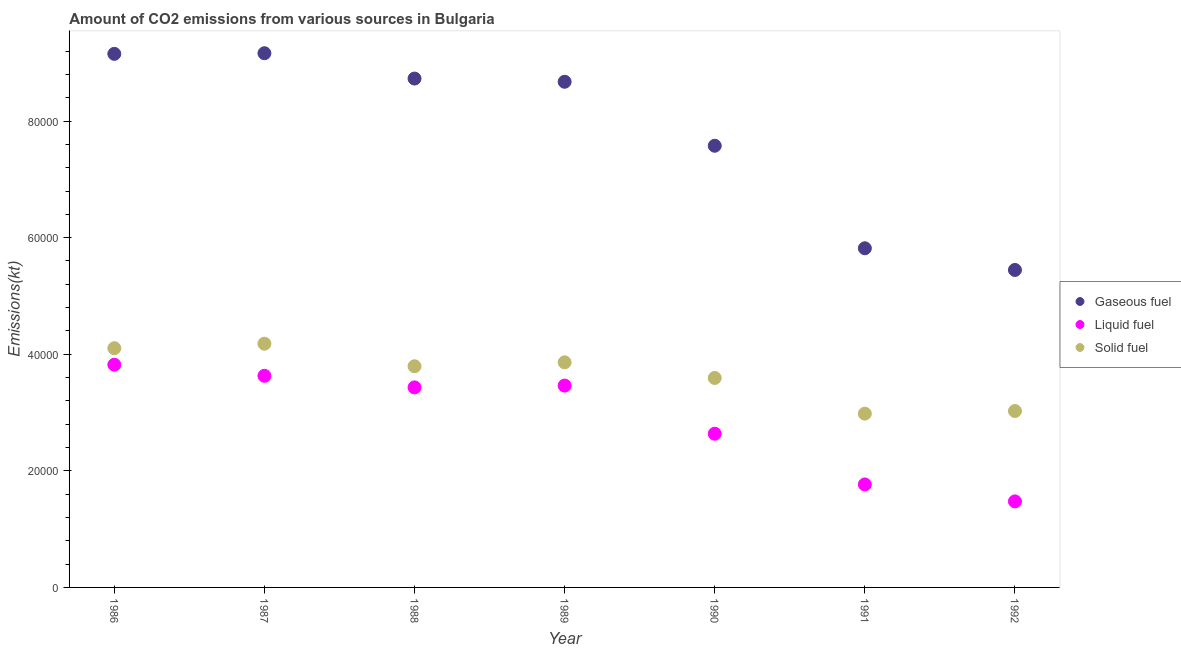Is the number of dotlines equal to the number of legend labels?
Keep it short and to the point. Yes. What is the amount of co2 emissions from liquid fuel in 1989?
Provide a short and direct response. 3.46e+04. Across all years, what is the maximum amount of co2 emissions from solid fuel?
Your answer should be very brief. 4.18e+04. Across all years, what is the minimum amount of co2 emissions from liquid fuel?
Your answer should be compact. 1.48e+04. In which year was the amount of co2 emissions from gaseous fuel minimum?
Your response must be concise. 1992. What is the total amount of co2 emissions from liquid fuel in the graph?
Your answer should be compact. 2.02e+05. What is the difference between the amount of co2 emissions from liquid fuel in 1987 and that in 1990?
Make the answer very short. 9937.57. What is the difference between the amount of co2 emissions from gaseous fuel in 1990 and the amount of co2 emissions from liquid fuel in 1986?
Your answer should be compact. 3.76e+04. What is the average amount of co2 emissions from solid fuel per year?
Your answer should be compact. 3.65e+04. In the year 1989, what is the difference between the amount of co2 emissions from solid fuel and amount of co2 emissions from liquid fuel?
Make the answer very short. 3986.03. What is the ratio of the amount of co2 emissions from gaseous fuel in 1986 to that in 1991?
Make the answer very short. 1.57. Is the amount of co2 emissions from solid fuel in 1987 less than that in 1989?
Make the answer very short. No. Is the difference between the amount of co2 emissions from gaseous fuel in 1989 and 1991 greater than the difference between the amount of co2 emissions from liquid fuel in 1989 and 1991?
Your answer should be compact. Yes. What is the difference between the highest and the second highest amount of co2 emissions from liquid fuel?
Offer a terse response. 1903.17. What is the difference between the highest and the lowest amount of co2 emissions from gaseous fuel?
Make the answer very short. 3.72e+04. Does the amount of co2 emissions from liquid fuel monotonically increase over the years?
Provide a succinct answer. No. Is the amount of co2 emissions from gaseous fuel strictly less than the amount of co2 emissions from solid fuel over the years?
Offer a terse response. No. How many years are there in the graph?
Your answer should be very brief. 7. What is the difference between two consecutive major ticks on the Y-axis?
Offer a terse response. 2.00e+04. How are the legend labels stacked?
Give a very brief answer. Vertical. What is the title of the graph?
Ensure brevity in your answer.  Amount of CO2 emissions from various sources in Bulgaria. Does "Unemployment benefits" appear as one of the legend labels in the graph?
Keep it short and to the point. No. What is the label or title of the X-axis?
Make the answer very short. Year. What is the label or title of the Y-axis?
Offer a terse response. Emissions(kt). What is the Emissions(kt) of Gaseous fuel in 1986?
Your answer should be compact. 9.15e+04. What is the Emissions(kt) of Liquid fuel in 1986?
Ensure brevity in your answer.  3.82e+04. What is the Emissions(kt) of Solid fuel in 1986?
Your answer should be compact. 4.10e+04. What is the Emissions(kt) in Gaseous fuel in 1987?
Your answer should be very brief. 9.16e+04. What is the Emissions(kt) of Liquid fuel in 1987?
Make the answer very short. 3.63e+04. What is the Emissions(kt) in Solid fuel in 1987?
Provide a succinct answer. 4.18e+04. What is the Emissions(kt) of Gaseous fuel in 1988?
Your answer should be very brief. 8.73e+04. What is the Emissions(kt) in Liquid fuel in 1988?
Make the answer very short. 3.43e+04. What is the Emissions(kt) of Solid fuel in 1988?
Your response must be concise. 3.79e+04. What is the Emissions(kt) in Gaseous fuel in 1989?
Your response must be concise. 8.67e+04. What is the Emissions(kt) in Liquid fuel in 1989?
Provide a short and direct response. 3.46e+04. What is the Emissions(kt) in Solid fuel in 1989?
Your answer should be very brief. 3.86e+04. What is the Emissions(kt) of Gaseous fuel in 1990?
Your answer should be very brief. 7.58e+04. What is the Emissions(kt) in Liquid fuel in 1990?
Offer a very short reply. 2.64e+04. What is the Emissions(kt) of Solid fuel in 1990?
Offer a terse response. 3.59e+04. What is the Emissions(kt) in Gaseous fuel in 1991?
Offer a very short reply. 5.82e+04. What is the Emissions(kt) of Liquid fuel in 1991?
Give a very brief answer. 1.77e+04. What is the Emissions(kt) in Solid fuel in 1991?
Give a very brief answer. 2.98e+04. What is the Emissions(kt) of Gaseous fuel in 1992?
Provide a succinct answer. 5.45e+04. What is the Emissions(kt) in Liquid fuel in 1992?
Ensure brevity in your answer.  1.48e+04. What is the Emissions(kt) of Solid fuel in 1992?
Ensure brevity in your answer.  3.03e+04. Across all years, what is the maximum Emissions(kt) in Gaseous fuel?
Keep it short and to the point. 9.16e+04. Across all years, what is the maximum Emissions(kt) in Liquid fuel?
Provide a short and direct response. 3.82e+04. Across all years, what is the maximum Emissions(kt) in Solid fuel?
Offer a very short reply. 4.18e+04. Across all years, what is the minimum Emissions(kt) in Gaseous fuel?
Your response must be concise. 5.45e+04. Across all years, what is the minimum Emissions(kt) in Liquid fuel?
Make the answer very short. 1.48e+04. Across all years, what is the minimum Emissions(kt) of Solid fuel?
Give a very brief answer. 2.98e+04. What is the total Emissions(kt) in Gaseous fuel in the graph?
Offer a very short reply. 5.46e+05. What is the total Emissions(kt) of Liquid fuel in the graph?
Give a very brief answer. 2.02e+05. What is the total Emissions(kt) of Solid fuel in the graph?
Offer a terse response. 2.55e+05. What is the difference between the Emissions(kt) in Gaseous fuel in 1986 and that in 1987?
Offer a very short reply. -106.34. What is the difference between the Emissions(kt) of Liquid fuel in 1986 and that in 1987?
Your answer should be compact. 1903.17. What is the difference between the Emissions(kt) in Solid fuel in 1986 and that in 1987?
Offer a terse response. -770.07. What is the difference between the Emissions(kt) in Gaseous fuel in 1986 and that in 1988?
Offer a very short reply. 4239.05. What is the difference between the Emissions(kt) of Liquid fuel in 1986 and that in 1988?
Provide a short and direct response. 3887.02. What is the difference between the Emissions(kt) of Solid fuel in 1986 and that in 1988?
Make the answer very short. 3098.61. What is the difference between the Emissions(kt) in Gaseous fuel in 1986 and that in 1989?
Offer a terse response. 4789.1. What is the difference between the Emissions(kt) of Liquid fuel in 1986 and that in 1989?
Your answer should be compact. 3578.99. What is the difference between the Emissions(kt) in Solid fuel in 1986 and that in 1989?
Provide a succinct answer. 2427.55. What is the difference between the Emissions(kt) in Gaseous fuel in 1986 and that in 1990?
Give a very brief answer. 1.58e+04. What is the difference between the Emissions(kt) of Liquid fuel in 1986 and that in 1990?
Offer a terse response. 1.18e+04. What is the difference between the Emissions(kt) in Solid fuel in 1986 and that in 1990?
Keep it short and to the point. 5104.46. What is the difference between the Emissions(kt) of Gaseous fuel in 1986 and that in 1991?
Provide a short and direct response. 3.34e+04. What is the difference between the Emissions(kt) of Liquid fuel in 1986 and that in 1991?
Your response must be concise. 2.05e+04. What is the difference between the Emissions(kt) of Solid fuel in 1986 and that in 1991?
Your answer should be very brief. 1.12e+04. What is the difference between the Emissions(kt) of Gaseous fuel in 1986 and that in 1992?
Keep it short and to the point. 3.71e+04. What is the difference between the Emissions(kt) in Liquid fuel in 1986 and that in 1992?
Provide a succinct answer. 2.34e+04. What is the difference between the Emissions(kt) of Solid fuel in 1986 and that in 1992?
Keep it short and to the point. 1.08e+04. What is the difference between the Emissions(kt) of Gaseous fuel in 1987 and that in 1988?
Offer a very short reply. 4345.4. What is the difference between the Emissions(kt) in Liquid fuel in 1987 and that in 1988?
Keep it short and to the point. 1983.85. What is the difference between the Emissions(kt) of Solid fuel in 1987 and that in 1988?
Your answer should be compact. 3868.68. What is the difference between the Emissions(kt) in Gaseous fuel in 1987 and that in 1989?
Your answer should be very brief. 4895.44. What is the difference between the Emissions(kt) in Liquid fuel in 1987 and that in 1989?
Give a very brief answer. 1675.82. What is the difference between the Emissions(kt) of Solid fuel in 1987 and that in 1989?
Offer a very short reply. 3197.62. What is the difference between the Emissions(kt) of Gaseous fuel in 1987 and that in 1990?
Keep it short and to the point. 1.59e+04. What is the difference between the Emissions(kt) in Liquid fuel in 1987 and that in 1990?
Keep it short and to the point. 9937.57. What is the difference between the Emissions(kt) of Solid fuel in 1987 and that in 1990?
Keep it short and to the point. 5874.53. What is the difference between the Emissions(kt) of Gaseous fuel in 1987 and that in 1991?
Offer a very short reply. 3.35e+04. What is the difference between the Emissions(kt) in Liquid fuel in 1987 and that in 1991?
Give a very brief answer. 1.86e+04. What is the difference between the Emissions(kt) in Solid fuel in 1987 and that in 1991?
Offer a very short reply. 1.20e+04. What is the difference between the Emissions(kt) in Gaseous fuel in 1987 and that in 1992?
Offer a very short reply. 3.72e+04. What is the difference between the Emissions(kt) in Liquid fuel in 1987 and that in 1992?
Provide a succinct answer. 2.15e+04. What is the difference between the Emissions(kt) in Solid fuel in 1987 and that in 1992?
Provide a short and direct response. 1.15e+04. What is the difference between the Emissions(kt) of Gaseous fuel in 1988 and that in 1989?
Make the answer very short. 550.05. What is the difference between the Emissions(kt) in Liquid fuel in 1988 and that in 1989?
Provide a succinct answer. -308.03. What is the difference between the Emissions(kt) in Solid fuel in 1988 and that in 1989?
Provide a short and direct response. -671.06. What is the difference between the Emissions(kt) in Gaseous fuel in 1988 and that in 1990?
Your response must be concise. 1.15e+04. What is the difference between the Emissions(kt) of Liquid fuel in 1988 and that in 1990?
Offer a terse response. 7953.72. What is the difference between the Emissions(kt) of Solid fuel in 1988 and that in 1990?
Ensure brevity in your answer.  2005.85. What is the difference between the Emissions(kt) in Gaseous fuel in 1988 and that in 1991?
Keep it short and to the point. 2.91e+04. What is the difference between the Emissions(kt) in Liquid fuel in 1988 and that in 1991?
Offer a very short reply. 1.66e+04. What is the difference between the Emissions(kt) in Solid fuel in 1988 and that in 1991?
Your response must be concise. 8129.74. What is the difference between the Emissions(kt) in Gaseous fuel in 1988 and that in 1992?
Your answer should be very brief. 3.28e+04. What is the difference between the Emissions(kt) of Liquid fuel in 1988 and that in 1992?
Your answer should be very brief. 1.96e+04. What is the difference between the Emissions(kt) of Solid fuel in 1988 and that in 1992?
Offer a terse response. 7678.7. What is the difference between the Emissions(kt) in Gaseous fuel in 1989 and that in 1990?
Your answer should be very brief. 1.10e+04. What is the difference between the Emissions(kt) of Liquid fuel in 1989 and that in 1990?
Your answer should be very brief. 8261.75. What is the difference between the Emissions(kt) of Solid fuel in 1989 and that in 1990?
Make the answer very short. 2676.91. What is the difference between the Emissions(kt) in Gaseous fuel in 1989 and that in 1991?
Offer a terse response. 2.86e+04. What is the difference between the Emissions(kt) in Liquid fuel in 1989 and that in 1991?
Offer a terse response. 1.70e+04. What is the difference between the Emissions(kt) in Solid fuel in 1989 and that in 1991?
Give a very brief answer. 8800.8. What is the difference between the Emissions(kt) in Gaseous fuel in 1989 and that in 1992?
Your answer should be compact. 3.23e+04. What is the difference between the Emissions(kt) of Liquid fuel in 1989 and that in 1992?
Offer a very short reply. 1.99e+04. What is the difference between the Emissions(kt) of Solid fuel in 1989 and that in 1992?
Your answer should be very brief. 8349.76. What is the difference between the Emissions(kt) in Gaseous fuel in 1990 and that in 1991?
Offer a terse response. 1.76e+04. What is the difference between the Emissions(kt) of Liquid fuel in 1990 and that in 1991?
Make the answer very short. 8694.46. What is the difference between the Emissions(kt) in Solid fuel in 1990 and that in 1991?
Offer a very short reply. 6123.89. What is the difference between the Emissions(kt) of Gaseous fuel in 1990 and that in 1992?
Keep it short and to the point. 2.13e+04. What is the difference between the Emissions(kt) in Liquid fuel in 1990 and that in 1992?
Keep it short and to the point. 1.16e+04. What is the difference between the Emissions(kt) in Solid fuel in 1990 and that in 1992?
Ensure brevity in your answer.  5672.85. What is the difference between the Emissions(kt) in Gaseous fuel in 1991 and that in 1992?
Your answer should be compact. 3718.34. What is the difference between the Emissions(kt) in Liquid fuel in 1991 and that in 1992?
Your response must be concise. 2907.93. What is the difference between the Emissions(kt) in Solid fuel in 1991 and that in 1992?
Your answer should be very brief. -451.04. What is the difference between the Emissions(kt) of Gaseous fuel in 1986 and the Emissions(kt) of Liquid fuel in 1987?
Keep it short and to the point. 5.52e+04. What is the difference between the Emissions(kt) of Gaseous fuel in 1986 and the Emissions(kt) of Solid fuel in 1987?
Offer a very short reply. 4.97e+04. What is the difference between the Emissions(kt) of Liquid fuel in 1986 and the Emissions(kt) of Solid fuel in 1987?
Your answer should be very brief. -3604.66. What is the difference between the Emissions(kt) in Gaseous fuel in 1986 and the Emissions(kt) in Liquid fuel in 1988?
Your answer should be compact. 5.72e+04. What is the difference between the Emissions(kt) in Gaseous fuel in 1986 and the Emissions(kt) in Solid fuel in 1988?
Offer a very short reply. 5.36e+04. What is the difference between the Emissions(kt) in Liquid fuel in 1986 and the Emissions(kt) in Solid fuel in 1988?
Provide a succinct answer. 264.02. What is the difference between the Emissions(kt) of Gaseous fuel in 1986 and the Emissions(kt) of Liquid fuel in 1989?
Provide a succinct answer. 5.69e+04. What is the difference between the Emissions(kt) in Gaseous fuel in 1986 and the Emissions(kt) in Solid fuel in 1989?
Ensure brevity in your answer.  5.29e+04. What is the difference between the Emissions(kt) of Liquid fuel in 1986 and the Emissions(kt) of Solid fuel in 1989?
Keep it short and to the point. -407.04. What is the difference between the Emissions(kt) in Gaseous fuel in 1986 and the Emissions(kt) in Liquid fuel in 1990?
Your answer should be compact. 6.52e+04. What is the difference between the Emissions(kt) in Gaseous fuel in 1986 and the Emissions(kt) in Solid fuel in 1990?
Keep it short and to the point. 5.56e+04. What is the difference between the Emissions(kt) in Liquid fuel in 1986 and the Emissions(kt) in Solid fuel in 1990?
Offer a terse response. 2269.87. What is the difference between the Emissions(kt) of Gaseous fuel in 1986 and the Emissions(kt) of Liquid fuel in 1991?
Provide a short and direct response. 7.39e+04. What is the difference between the Emissions(kt) of Gaseous fuel in 1986 and the Emissions(kt) of Solid fuel in 1991?
Your response must be concise. 6.17e+04. What is the difference between the Emissions(kt) of Liquid fuel in 1986 and the Emissions(kt) of Solid fuel in 1991?
Provide a succinct answer. 8393.76. What is the difference between the Emissions(kt) of Gaseous fuel in 1986 and the Emissions(kt) of Liquid fuel in 1992?
Keep it short and to the point. 7.68e+04. What is the difference between the Emissions(kt) of Gaseous fuel in 1986 and the Emissions(kt) of Solid fuel in 1992?
Your answer should be very brief. 6.13e+04. What is the difference between the Emissions(kt) in Liquid fuel in 1986 and the Emissions(kt) in Solid fuel in 1992?
Your response must be concise. 7942.72. What is the difference between the Emissions(kt) of Gaseous fuel in 1987 and the Emissions(kt) of Liquid fuel in 1988?
Provide a succinct answer. 5.73e+04. What is the difference between the Emissions(kt) in Gaseous fuel in 1987 and the Emissions(kt) in Solid fuel in 1988?
Ensure brevity in your answer.  5.37e+04. What is the difference between the Emissions(kt) in Liquid fuel in 1987 and the Emissions(kt) in Solid fuel in 1988?
Provide a short and direct response. -1639.15. What is the difference between the Emissions(kt) in Gaseous fuel in 1987 and the Emissions(kt) in Liquid fuel in 1989?
Provide a short and direct response. 5.70e+04. What is the difference between the Emissions(kt) in Gaseous fuel in 1987 and the Emissions(kt) in Solid fuel in 1989?
Your answer should be very brief. 5.30e+04. What is the difference between the Emissions(kt) in Liquid fuel in 1987 and the Emissions(kt) in Solid fuel in 1989?
Your answer should be very brief. -2310.21. What is the difference between the Emissions(kt) of Gaseous fuel in 1987 and the Emissions(kt) of Liquid fuel in 1990?
Provide a succinct answer. 6.53e+04. What is the difference between the Emissions(kt) in Gaseous fuel in 1987 and the Emissions(kt) in Solid fuel in 1990?
Offer a terse response. 5.57e+04. What is the difference between the Emissions(kt) in Liquid fuel in 1987 and the Emissions(kt) in Solid fuel in 1990?
Offer a terse response. 366.7. What is the difference between the Emissions(kt) in Gaseous fuel in 1987 and the Emissions(kt) in Liquid fuel in 1991?
Make the answer very short. 7.40e+04. What is the difference between the Emissions(kt) in Gaseous fuel in 1987 and the Emissions(kt) in Solid fuel in 1991?
Keep it short and to the point. 6.18e+04. What is the difference between the Emissions(kt) of Liquid fuel in 1987 and the Emissions(kt) of Solid fuel in 1991?
Provide a short and direct response. 6490.59. What is the difference between the Emissions(kt) of Gaseous fuel in 1987 and the Emissions(kt) of Liquid fuel in 1992?
Your answer should be compact. 7.69e+04. What is the difference between the Emissions(kt) of Gaseous fuel in 1987 and the Emissions(kt) of Solid fuel in 1992?
Your response must be concise. 6.14e+04. What is the difference between the Emissions(kt) of Liquid fuel in 1987 and the Emissions(kt) of Solid fuel in 1992?
Keep it short and to the point. 6039.55. What is the difference between the Emissions(kt) of Gaseous fuel in 1988 and the Emissions(kt) of Liquid fuel in 1989?
Keep it short and to the point. 5.27e+04. What is the difference between the Emissions(kt) of Gaseous fuel in 1988 and the Emissions(kt) of Solid fuel in 1989?
Ensure brevity in your answer.  4.87e+04. What is the difference between the Emissions(kt) of Liquid fuel in 1988 and the Emissions(kt) of Solid fuel in 1989?
Your answer should be compact. -4294.06. What is the difference between the Emissions(kt) in Gaseous fuel in 1988 and the Emissions(kt) in Liquid fuel in 1990?
Keep it short and to the point. 6.09e+04. What is the difference between the Emissions(kt) in Gaseous fuel in 1988 and the Emissions(kt) in Solid fuel in 1990?
Your answer should be compact. 5.14e+04. What is the difference between the Emissions(kt) of Liquid fuel in 1988 and the Emissions(kt) of Solid fuel in 1990?
Provide a short and direct response. -1617.15. What is the difference between the Emissions(kt) of Gaseous fuel in 1988 and the Emissions(kt) of Liquid fuel in 1991?
Provide a short and direct response. 6.96e+04. What is the difference between the Emissions(kt) in Gaseous fuel in 1988 and the Emissions(kt) in Solid fuel in 1991?
Your answer should be very brief. 5.75e+04. What is the difference between the Emissions(kt) of Liquid fuel in 1988 and the Emissions(kt) of Solid fuel in 1991?
Make the answer very short. 4506.74. What is the difference between the Emissions(kt) in Gaseous fuel in 1988 and the Emissions(kt) in Liquid fuel in 1992?
Give a very brief answer. 7.25e+04. What is the difference between the Emissions(kt) in Gaseous fuel in 1988 and the Emissions(kt) in Solid fuel in 1992?
Keep it short and to the point. 5.70e+04. What is the difference between the Emissions(kt) of Liquid fuel in 1988 and the Emissions(kt) of Solid fuel in 1992?
Give a very brief answer. 4055.7. What is the difference between the Emissions(kt) in Gaseous fuel in 1989 and the Emissions(kt) in Liquid fuel in 1990?
Give a very brief answer. 6.04e+04. What is the difference between the Emissions(kt) of Gaseous fuel in 1989 and the Emissions(kt) of Solid fuel in 1990?
Your answer should be very brief. 5.08e+04. What is the difference between the Emissions(kt) of Liquid fuel in 1989 and the Emissions(kt) of Solid fuel in 1990?
Give a very brief answer. -1309.12. What is the difference between the Emissions(kt) of Gaseous fuel in 1989 and the Emissions(kt) of Liquid fuel in 1991?
Ensure brevity in your answer.  6.91e+04. What is the difference between the Emissions(kt) in Gaseous fuel in 1989 and the Emissions(kt) in Solid fuel in 1991?
Your answer should be compact. 5.69e+04. What is the difference between the Emissions(kt) of Liquid fuel in 1989 and the Emissions(kt) of Solid fuel in 1991?
Offer a very short reply. 4814.77. What is the difference between the Emissions(kt) of Gaseous fuel in 1989 and the Emissions(kt) of Liquid fuel in 1992?
Ensure brevity in your answer.  7.20e+04. What is the difference between the Emissions(kt) of Gaseous fuel in 1989 and the Emissions(kt) of Solid fuel in 1992?
Make the answer very short. 5.65e+04. What is the difference between the Emissions(kt) of Liquid fuel in 1989 and the Emissions(kt) of Solid fuel in 1992?
Your answer should be very brief. 4363.73. What is the difference between the Emissions(kt) of Gaseous fuel in 1990 and the Emissions(kt) of Liquid fuel in 1991?
Provide a succinct answer. 5.81e+04. What is the difference between the Emissions(kt) of Gaseous fuel in 1990 and the Emissions(kt) of Solid fuel in 1991?
Make the answer very short. 4.60e+04. What is the difference between the Emissions(kt) in Liquid fuel in 1990 and the Emissions(kt) in Solid fuel in 1991?
Your response must be concise. -3446.98. What is the difference between the Emissions(kt) of Gaseous fuel in 1990 and the Emissions(kt) of Liquid fuel in 1992?
Your answer should be very brief. 6.10e+04. What is the difference between the Emissions(kt) in Gaseous fuel in 1990 and the Emissions(kt) in Solid fuel in 1992?
Make the answer very short. 4.55e+04. What is the difference between the Emissions(kt) of Liquid fuel in 1990 and the Emissions(kt) of Solid fuel in 1992?
Provide a succinct answer. -3898.02. What is the difference between the Emissions(kt) in Gaseous fuel in 1991 and the Emissions(kt) in Liquid fuel in 1992?
Your answer should be very brief. 4.34e+04. What is the difference between the Emissions(kt) of Gaseous fuel in 1991 and the Emissions(kt) of Solid fuel in 1992?
Provide a succinct answer. 2.79e+04. What is the difference between the Emissions(kt) of Liquid fuel in 1991 and the Emissions(kt) of Solid fuel in 1992?
Ensure brevity in your answer.  -1.26e+04. What is the average Emissions(kt) of Gaseous fuel per year?
Give a very brief answer. 7.79e+04. What is the average Emissions(kt) in Liquid fuel per year?
Ensure brevity in your answer.  2.89e+04. What is the average Emissions(kt) in Solid fuel per year?
Your answer should be very brief. 3.65e+04. In the year 1986, what is the difference between the Emissions(kt) in Gaseous fuel and Emissions(kt) in Liquid fuel?
Your answer should be very brief. 5.33e+04. In the year 1986, what is the difference between the Emissions(kt) of Gaseous fuel and Emissions(kt) of Solid fuel?
Give a very brief answer. 5.05e+04. In the year 1986, what is the difference between the Emissions(kt) in Liquid fuel and Emissions(kt) in Solid fuel?
Provide a short and direct response. -2834.59. In the year 1987, what is the difference between the Emissions(kt) of Gaseous fuel and Emissions(kt) of Liquid fuel?
Give a very brief answer. 5.53e+04. In the year 1987, what is the difference between the Emissions(kt) in Gaseous fuel and Emissions(kt) in Solid fuel?
Offer a very short reply. 4.98e+04. In the year 1987, what is the difference between the Emissions(kt) of Liquid fuel and Emissions(kt) of Solid fuel?
Keep it short and to the point. -5507.83. In the year 1988, what is the difference between the Emissions(kt) of Gaseous fuel and Emissions(kt) of Liquid fuel?
Your answer should be compact. 5.30e+04. In the year 1988, what is the difference between the Emissions(kt) of Gaseous fuel and Emissions(kt) of Solid fuel?
Your answer should be very brief. 4.94e+04. In the year 1988, what is the difference between the Emissions(kt) of Liquid fuel and Emissions(kt) of Solid fuel?
Provide a short and direct response. -3623. In the year 1989, what is the difference between the Emissions(kt) of Gaseous fuel and Emissions(kt) of Liquid fuel?
Keep it short and to the point. 5.21e+04. In the year 1989, what is the difference between the Emissions(kt) of Gaseous fuel and Emissions(kt) of Solid fuel?
Make the answer very short. 4.81e+04. In the year 1989, what is the difference between the Emissions(kt) of Liquid fuel and Emissions(kt) of Solid fuel?
Keep it short and to the point. -3986.03. In the year 1990, what is the difference between the Emissions(kt) in Gaseous fuel and Emissions(kt) in Liquid fuel?
Offer a very short reply. 4.94e+04. In the year 1990, what is the difference between the Emissions(kt) of Gaseous fuel and Emissions(kt) of Solid fuel?
Give a very brief answer. 3.98e+04. In the year 1990, what is the difference between the Emissions(kt) of Liquid fuel and Emissions(kt) of Solid fuel?
Your answer should be very brief. -9570.87. In the year 1991, what is the difference between the Emissions(kt) of Gaseous fuel and Emissions(kt) of Liquid fuel?
Your answer should be very brief. 4.05e+04. In the year 1991, what is the difference between the Emissions(kt) of Gaseous fuel and Emissions(kt) of Solid fuel?
Keep it short and to the point. 2.84e+04. In the year 1991, what is the difference between the Emissions(kt) in Liquid fuel and Emissions(kt) in Solid fuel?
Your answer should be very brief. -1.21e+04. In the year 1992, what is the difference between the Emissions(kt) in Gaseous fuel and Emissions(kt) in Liquid fuel?
Your answer should be compact. 3.97e+04. In the year 1992, what is the difference between the Emissions(kt) of Gaseous fuel and Emissions(kt) of Solid fuel?
Provide a short and direct response. 2.42e+04. In the year 1992, what is the difference between the Emissions(kt) of Liquid fuel and Emissions(kt) of Solid fuel?
Your answer should be compact. -1.55e+04. What is the ratio of the Emissions(kt) in Liquid fuel in 1986 to that in 1987?
Your answer should be very brief. 1.05. What is the ratio of the Emissions(kt) in Solid fuel in 1986 to that in 1987?
Keep it short and to the point. 0.98. What is the ratio of the Emissions(kt) in Gaseous fuel in 1986 to that in 1988?
Make the answer very short. 1.05. What is the ratio of the Emissions(kt) of Liquid fuel in 1986 to that in 1988?
Your answer should be very brief. 1.11. What is the ratio of the Emissions(kt) in Solid fuel in 1986 to that in 1988?
Ensure brevity in your answer.  1.08. What is the ratio of the Emissions(kt) in Gaseous fuel in 1986 to that in 1989?
Provide a succinct answer. 1.06. What is the ratio of the Emissions(kt) of Liquid fuel in 1986 to that in 1989?
Offer a very short reply. 1.1. What is the ratio of the Emissions(kt) in Solid fuel in 1986 to that in 1989?
Provide a short and direct response. 1.06. What is the ratio of the Emissions(kt) of Gaseous fuel in 1986 to that in 1990?
Make the answer very short. 1.21. What is the ratio of the Emissions(kt) of Liquid fuel in 1986 to that in 1990?
Your response must be concise. 1.45. What is the ratio of the Emissions(kt) of Solid fuel in 1986 to that in 1990?
Your answer should be compact. 1.14. What is the ratio of the Emissions(kt) of Gaseous fuel in 1986 to that in 1991?
Your response must be concise. 1.57. What is the ratio of the Emissions(kt) in Liquid fuel in 1986 to that in 1991?
Offer a very short reply. 2.16. What is the ratio of the Emissions(kt) in Solid fuel in 1986 to that in 1991?
Offer a terse response. 1.38. What is the ratio of the Emissions(kt) of Gaseous fuel in 1986 to that in 1992?
Offer a very short reply. 1.68. What is the ratio of the Emissions(kt) in Liquid fuel in 1986 to that in 1992?
Ensure brevity in your answer.  2.59. What is the ratio of the Emissions(kt) in Solid fuel in 1986 to that in 1992?
Ensure brevity in your answer.  1.36. What is the ratio of the Emissions(kt) of Gaseous fuel in 1987 to that in 1988?
Give a very brief answer. 1.05. What is the ratio of the Emissions(kt) of Liquid fuel in 1987 to that in 1988?
Your response must be concise. 1.06. What is the ratio of the Emissions(kt) of Solid fuel in 1987 to that in 1988?
Give a very brief answer. 1.1. What is the ratio of the Emissions(kt) in Gaseous fuel in 1987 to that in 1989?
Provide a short and direct response. 1.06. What is the ratio of the Emissions(kt) of Liquid fuel in 1987 to that in 1989?
Ensure brevity in your answer.  1.05. What is the ratio of the Emissions(kt) in Solid fuel in 1987 to that in 1989?
Your response must be concise. 1.08. What is the ratio of the Emissions(kt) in Gaseous fuel in 1987 to that in 1990?
Provide a succinct answer. 1.21. What is the ratio of the Emissions(kt) of Liquid fuel in 1987 to that in 1990?
Your answer should be compact. 1.38. What is the ratio of the Emissions(kt) of Solid fuel in 1987 to that in 1990?
Offer a very short reply. 1.16. What is the ratio of the Emissions(kt) of Gaseous fuel in 1987 to that in 1991?
Make the answer very short. 1.58. What is the ratio of the Emissions(kt) in Liquid fuel in 1987 to that in 1991?
Your answer should be compact. 2.05. What is the ratio of the Emissions(kt) of Solid fuel in 1987 to that in 1991?
Offer a very short reply. 1.4. What is the ratio of the Emissions(kt) of Gaseous fuel in 1987 to that in 1992?
Provide a succinct answer. 1.68. What is the ratio of the Emissions(kt) of Liquid fuel in 1987 to that in 1992?
Keep it short and to the point. 2.46. What is the ratio of the Emissions(kt) of Solid fuel in 1987 to that in 1992?
Your answer should be compact. 1.38. What is the ratio of the Emissions(kt) in Solid fuel in 1988 to that in 1989?
Provide a short and direct response. 0.98. What is the ratio of the Emissions(kt) of Gaseous fuel in 1988 to that in 1990?
Give a very brief answer. 1.15. What is the ratio of the Emissions(kt) in Liquid fuel in 1988 to that in 1990?
Offer a terse response. 1.3. What is the ratio of the Emissions(kt) in Solid fuel in 1988 to that in 1990?
Ensure brevity in your answer.  1.06. What is the ratio of the Emissions(kt) of Gaseous fuel in 1988 to that in 1991?
Your answer should be compact. 1.5. What is the ratio of the Emissions(kt) of Liquid fuel in 1988 to that in 1991?
Ensure brevity in your answer.  1.94. What is the ratio of the Emissions(kt) in Solid fuel in 1988 to that in 1991?
Give a very brief answer. 1.27. What is the ratio of the Emissions(kt) in Gaseous fuel in 1988 to that in 1992?
Provide a short and direct response. 1.6. What is the ratio of the Emissions(kt) of Liquid fuel in 1988 to that in 1992?
Give a very brief answer. 2.33. What is the ratio of the Emissions(kt) of Solid fuel in 1988 to that in 1992?
Your response must be concise. 1.25. What is the ratio of the Emissions(kt) of Gaseous fuel in 1989 to that in 1990?
Your answer should be compact. 1.14. What is the ratio of the Emissions(kt) in Liquid fuel in 1989 to that in 1990?
Keep it short and to the point. 1.31. What is the ratio of the Emissions(kt) of Solid fuel in 1989 to that in 1990?
Provide a short and direct response. 1.07. What is the ratio of the Emissions(kt) of Gaseous fuel in 1989 to that in 1991?
Give a very brief answer. 1.49. What is the ratio of the Emissions(kt) of Liquid fuel in 1989 to that in 1991?
Give a very brief answer. 1.96. What is the ratio of the Emissions(kt) of Solid fuel in 1989 to that in 1991?
Keep it short and to the point. 1.3. What is the ratio of the Emissions(kt) of Gaseous fuel in 1989 to that in 1992?
Give a very brief answer. 1.59. What is the ratio of the Emissions(kt) in Liquid fuel in 1989 to that in 1992?
Make the answer very short. 2.35. What is the ratio of the Emissions(kt) in Solid fuel in 1989 to that in 1992?
Provide a short and direct response. 1.28. What is the ratio of the Emissions(kt) in Gaseous fuel in 1990 to that in 1991?
Give a very brief answer. 1.3. What is the ratio of the Emissions(kt) of Liquid fuel in 1990 to that in 1991?
Ensure brevity in your answer.  1.49. What is the ratio of the Emissions(kt) in Solid fuel in 1990 to that in 1991?
Provide a succinct answer. 1.21. What is the ratio of the Emissions(kt) of Gaseous fuel in 1990 to that in 1992?
Your response must be concise. 1.39. What is the ratio of the Emissions(kt) in Liquid fuel in 1990 to that in 1992?
Offer a very short reply. 1.79. What is the ratio of the Emissions(kt) in Solid fuel in 1990 to that in 1992?
Make the answer very short. 1.19. What is the ratio of the Emissions(kt) in Gaseous fuel in 1991 to that in 1992?
Offer a terse response. 1.07. What is the ratio of the Emissions(kt) in Liquid fuel in 1991 to that in 1992?
Offer a terse response. 1.2. What is the ratio of the Emissions(kt) in Solid fuel in 1991 to that in 1992?
Keep it short and to the point. 0.99. What is the difference between the highest and the second highest Emissions(kt) of Gaseous fuel?
Your answer should be compact. 106.34. What is the difference between the highest and the second highest Emissions(kt) of Liquid fuel?
Provide a succinct answer. 1903.17. What is the difference between the highest and the second highest Emissions(kt) in Solid fuel?
Your response must be concise. 770.07. What is the difference between the highest and the lowest Emissions(kt) in Gaseous fuel?
Your response must be concise. 3.72e+04. What is the difference between the highest and the lowest Emissions(kt) in Liquid fuel?
Provide a short and direct response. 2.34e+04. What is the difference between the highest and the lowest Emissions(kt) in Solid fuel?
Make the answer very short. 1.20e+04. 